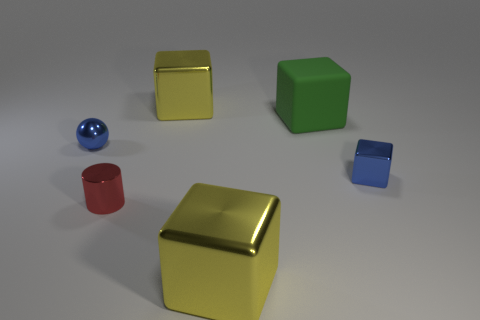How does the lighting in the image affect the appearance of the objects? The lighting in the image appears to come from above, casting subtle shadows directly beneath the objects, which helps to define their shapes and gives a sense of three-dimensionality. The reflective surfaces of the metallic and shiny objects, such as the golden-yellow and blue spheres, catch the light strongly, creating highlights and enhancing their luster. Meanwhile, the matte surfaces, like the red and green cubes, absorb more light, resulting in a softer appearance with less pronounced reflections. 